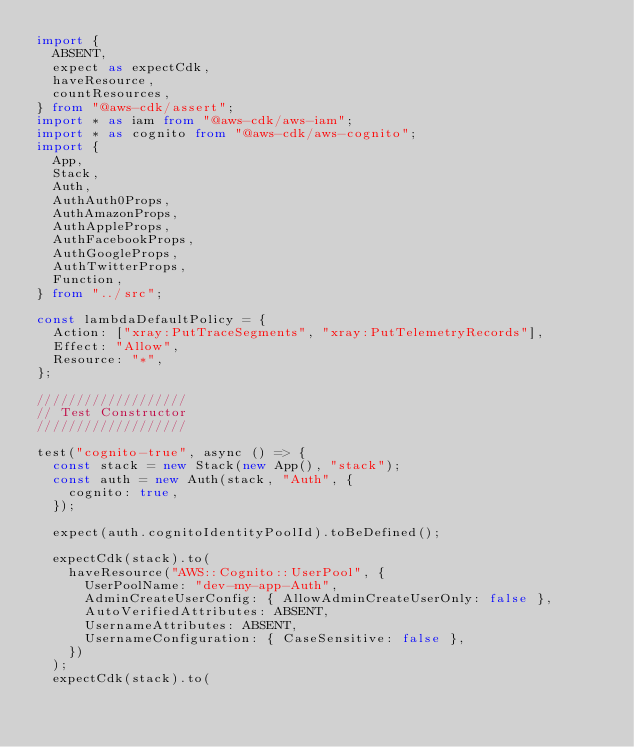<code> <loc_0><loc_0><loc_500><loc_500><_TypeScript_>import {
  ABSENT,
  expect as expectCdk,
  haveResource,
  countResources,
} from "@aws-cdk/assert";
import * as iam from "@aws-cdk/aws-iam";
import * as cognito from "@aws-cdk/aws-cognito";
import {
  App,
  Stack,
  Auth,
  AuthAuth0Props,
  AuthAmazonProps,
  AuthAppleProps,
  AuthFacebookProps,
  AuthGoogleProps,
  AuthTwitterProps,
  Function,
} from "../src";

const lambdaDefaultPolicy = {
  Action: ["xray:PutTraceSegments", "xray:PutTelemetryRecords"],
  Effect: "Allow",
  Resource: "*",
};

///////////////////
// Test Constructor
///////////////////

test("cognito-true", async () => {
  const stack = new Stack(new App(), "stack");
  const auth = new Auth(stack, "Auth", {
    cognito: true,
  });

  expect(auth.cognitoIdentityPoolId).toBeDefined();

  expectCdk(stack).to(
    haveResource("AWS::Cognito::UserPool", {
      UserPoolName: "dev-my-app-Auth",
      AdminCreateUserConfig: { AllowAdminCreateUserOnly: false },
      AutoVerifiedAttributes: ABSENT,
      UsernameAttributes: ABSENT,
      UsernameConfiguration: { CaseSensitive: false },
    })
  );
  expectCdk(stack).to(</code> 